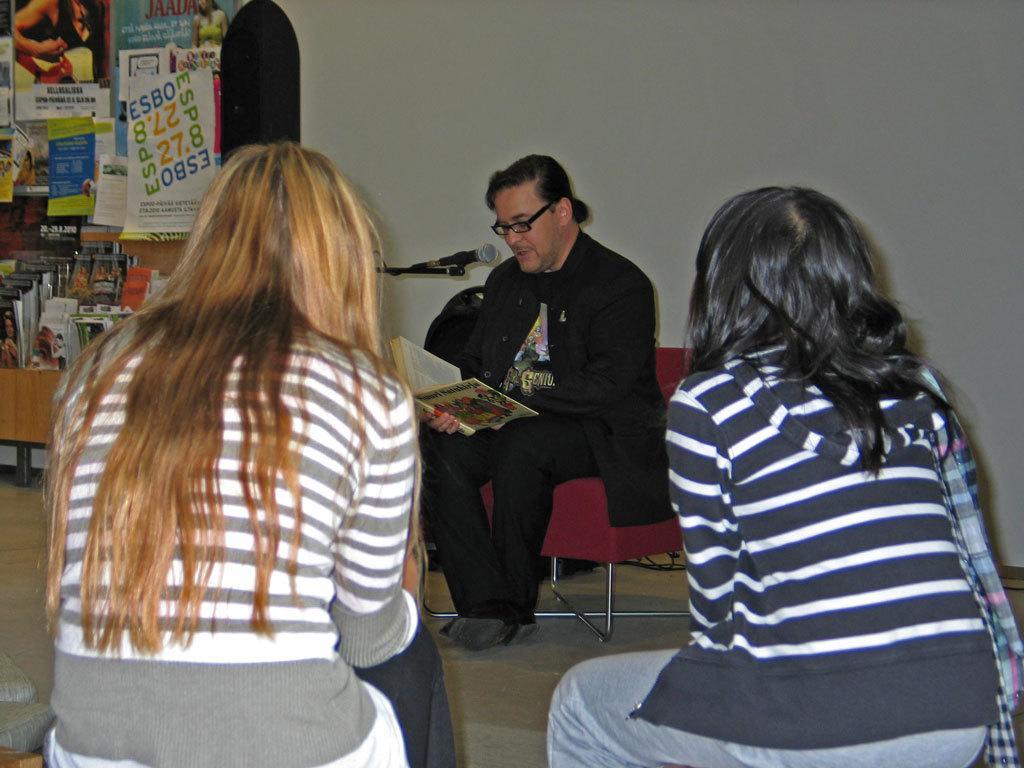Please provide a concise description of this image. In the image there are two ladies sitting. In front of them there is a man with black jacket is sitting on the chair and he is holding a book in his hand. In front of his mouth there is a mic. On the left side of the image there is a cupboard with many books in it and also there are many posters attached to the wall. 